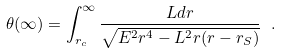<formula> <loc_0><loc_0><loc_500><loc_500>\theta ( \infty ) = \int _ { r _ { c } } ^ { \infty } \frac { L d r } { \sqrt { E ^ { 2 } r ^ { 4 } - L ^ { 2 } r ( r - r _ { S } ) } } \ .</formula> 